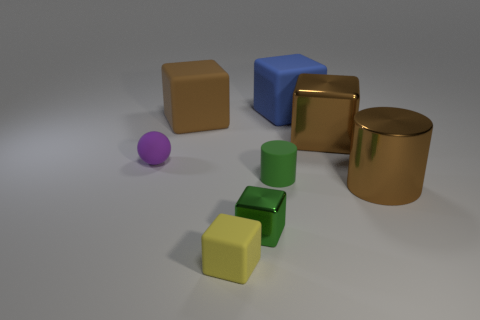Subtract all tiny matte cubes. How many cubes are left? 4 Add 1 blue cubes. How many objects exist? 9 Subtract all green cylinders. How many cylinders are left? 1 Subtract all red cylinders. How many brown blocks are left? 2 Add 4 red metallic things. How many red metallic things exist? 4 Subtract 0 gray spheres. How many objects are left? 8 Subtract all blocks. How many objects are left? 3 Subtract 1 cubes. How many cubes are left? 4 Subtract all blue spheres. Subtract all gray cylinders. How many spheres are left? 1 Subtract all brown spheres. Subtract all green cylinders. How many objects are left? 7 